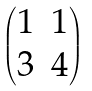Convert formula to latex. <formula><loc_0><loc_0><loc_500><loc_500>\begin{pmatrix} 1 & 1 \\ 3 & 4 \end{pmatrix}</formula> 